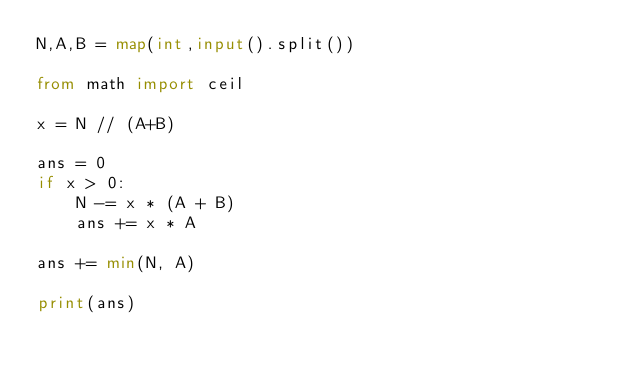<code> <loc_0><loc_0><loc_500><loc_500><_Python_>N,A,B = map(int,input().split())

from math import ceil

x = N // (A+B)

ans = 0
if x > 0:
    N -= x * (A + B)
    ans += x * A

ans += min(N, A)

print(ans)</code> 